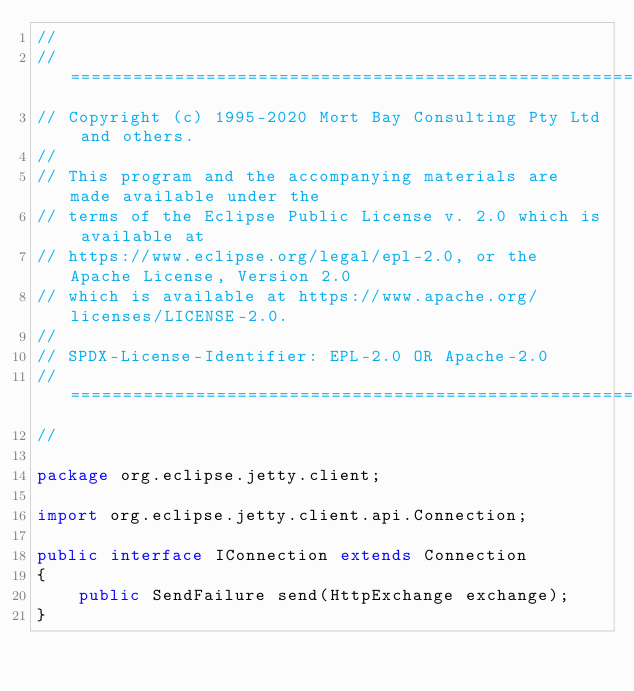Convert code to text. <code><loc_0><loc_0><loc_500><loc_500><_Java_>//
// ========================================================================
// Copyright (c) 1995-2020 Mort Bay Consulting Pty Ltd and others.
//
// This program and the accompanying materials are made available under the
// terms of the Eclipse Public License v. 2.0 which is available at
// https://www.eclipse.org/legal/epl-2.0, or the Apache License, Version 2.0
// which is available at https://www.apache.org/licenses/LICENSE-2.0.
//
// SPDX-License-Identifier: EPL-2.0 OR Apache-2.0
// ========================================================================
//

package org.eclipse.jetty.client;

import org.eclipse.jetty.client.api.Connection;

public interface IConnection extends Connection
{
    public SendFailure send(HttpExchange exchange);
}
</code> 